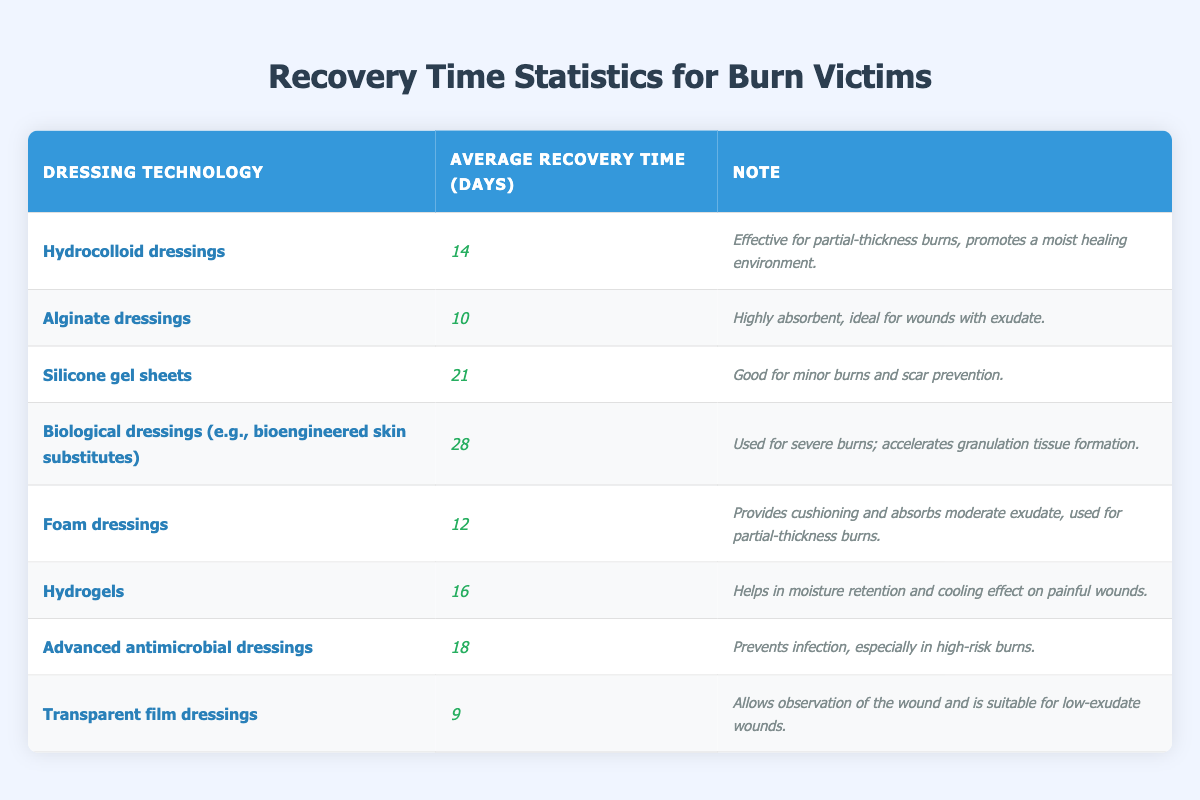What is the average recovery time for alginate dressings? The table states that the average recovery time for alginate dressings is 10 days.
Answer: 10 days Which dressing technology has the longest average recovery time? Referring to the table, biological dressings have the longest average recovery time at 28 days.
Answer: Biological dressings What is the average recovery time for foam dressings? According to the table, foam dressings have an average recovery time of 12 days.
Answer: 12 days True or False: Hydrocolloid dressings have a shorter recovery time than silicone gel sheets. The table shows that hydrocolloid dressings take 14 days, while silicone gel sheets take 21 days, making the statement true.
Answer: True What is the difference in average recovery time between advanced antimicrobial dressings and transparent film dressings? Advanced antimicrobial dressings have an average recovery time of 18 days and transparent film dressings have 9 days. The difference is 18 - 9 = 9 days.
Answer: 9 days If I combine the recovery times for hydrocolloid and foam dressings, what is their total? Hydrocolloid dressings have a recovery time of 14 days and foam dressings have 12 days. Adding these gives 14 + 12 = 26 days.
Answer: 26 days Which dressing technology is most suitable for low-exudate wounds? The table indicates that transparent film dressings are suitable for low-exudate wounds.
Answer: Transparent film dressings What is the median recovery time of all dressing technologies listed? Listing out the average recovery times in ascending order: 9, 10, 12, 14, 16, 18, 21, 28. With 8 values, the median is the average of the 4th and 5th values: (14+16)/2 = 15 days.
Answer: 15 days How many dressing technologies have an average recovery time of less than 15 days? The table lists alginate (10), foam (12), and transparent film (9) as having recovery times below 15 days. Therefore, there are three technologies.
Answer: 3 technologies What is the total average recovery time for dressing technologies recommended for severe burns? The table indicates that biological dressings (28 days) are for severe burns; thus, the total average recovery time is 28 days.
Answer: 28 days 